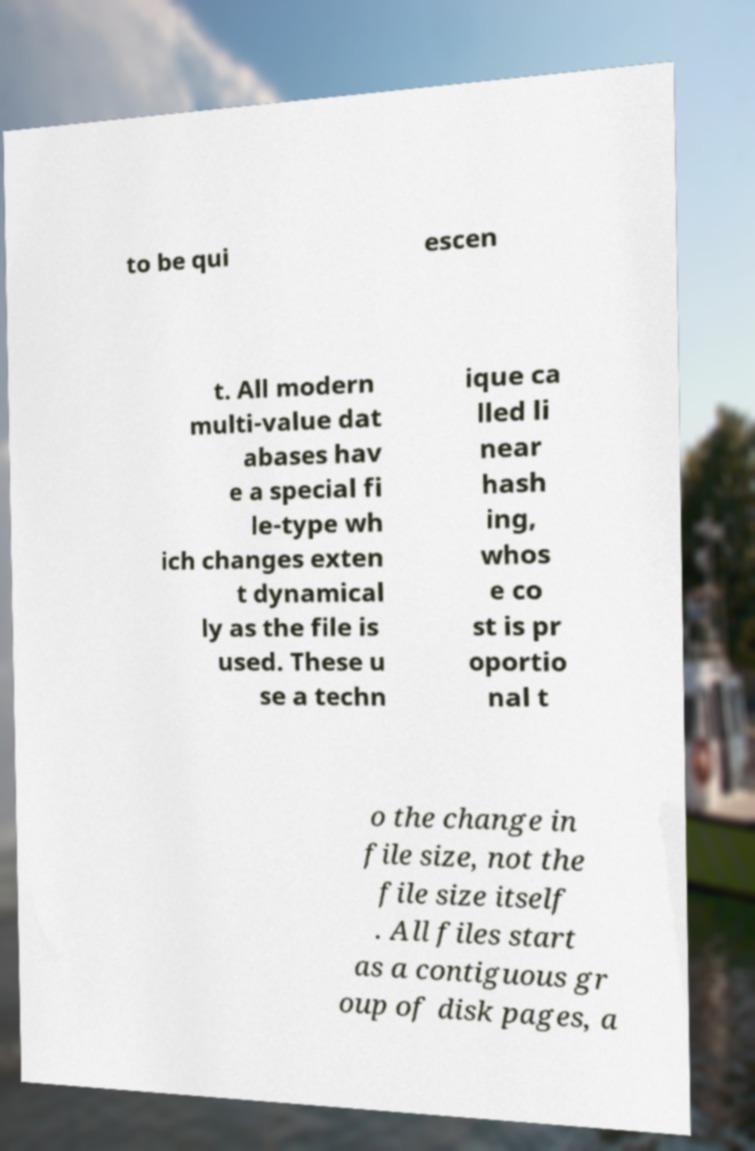For documentation purposes, I need the text within this image transcribed. Could you provide that? to be qui escen t. All modern multi-value dat abases hav e a special fi le-type wh ich changes exten t dynamical ly as the file is used. These u se a techn ique ca lled li near hash ing, whos e co st is pr oportio nal t o the change in file size, not the file size itself . All files start as a contiguous gr oup of disk pages, a 